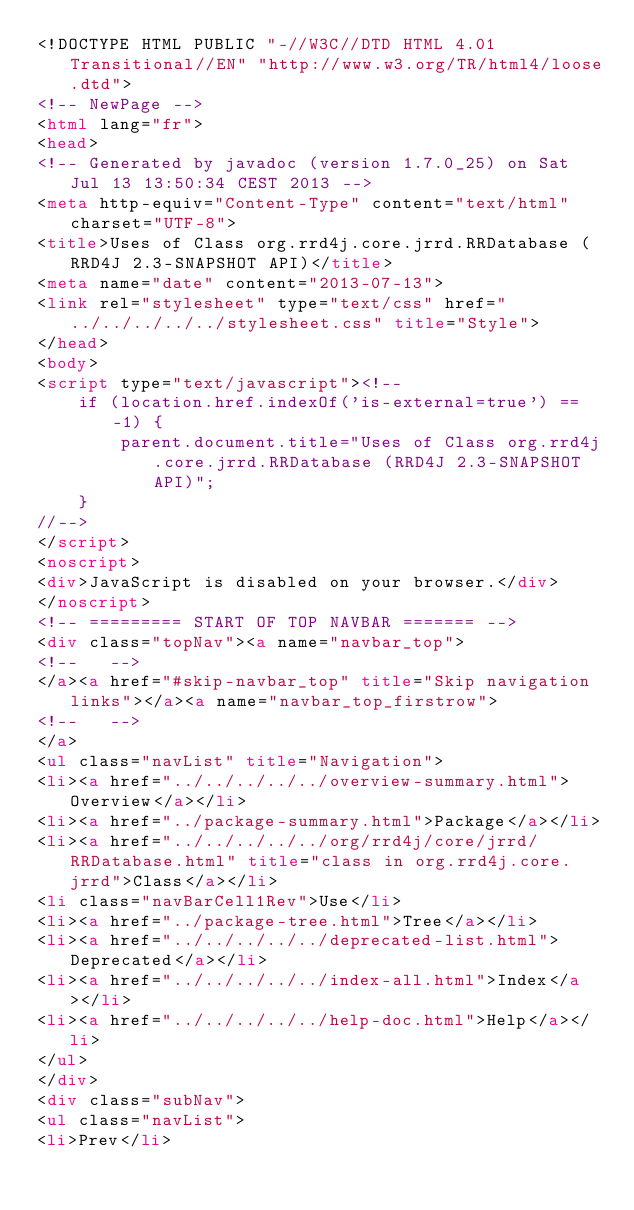<code> <loc_0><loc_0><loc_500><loc_500><_HTML_><!DOCTYPE HTML PUBLIC "-//W3C//DTD HTML 4.01 Transitional//EN" "http://www.w3.org/TR/html4/loose.dtd">
<!-- NewPage -->
<html lang="fr">
<head>
<!-- Generated by javadoc (version 1.7.0_25) on Sat Jul 13 13:50:34 CEST 2013 -->
<meta http-equiv="Content-Type" content="text/html" charset="UTF-8">
<title>Uses of Class org.rrd4j.core.jrrd.RRDatabase (RRD4J 2.3-SNAPSHOT API)</title>
<meta name="date" content="2013-07-13">
<link rel="stylesheet" type="text/css" href="../../../../../stylesheet.css" title="Style">
</head>
<body>
<script type="text/javascript"><!--
    if (location.href.indexOf('is-external=true') == -1) {
        parent.document.title="Uses of Class org.rrd4j.core.jrrd.RRDatabase (RRD4J 2.3-SNAPSHOT API)";
    }
//-->
</script>
<noscript>
<div>JavaScript is disabled on your browser.</div>
</noscript>
<!-- ========= START OF TOP NAVBAR ======= -->
<div class="topNav"><a name="navbar_top">
<!--   -->
</a><a href="#skip-navbar_top" title="Skip navigation links"></a><a name="navbar_top_firstrow">
<!--   -->
</a>
<ul class="navList" title="Navigation">
<li><a href="../../../../../overview-summary.html">Overview</a></li>
<li><a href="../package-summary.html">Package</a></li>
<li><a href="../../../../../org/rrd4j/core/jrrd/RRDatabase.html" title="class in org.rrd4j.core.jrrd">Class</a></li>
<li class="navBarCell1Rev">Use</li>
<li><a href="../package-tree.html">Tree</a></li>
<li><a href="../../../../../deprecated-list.html">Deprecated</a></li>
<li><a href="../../../../../index-all.html">Index</a></li>
<li><a href="../../../../../help-doc.html">Help</a></li>
</ul>
</div>
<div class="subNav">
<ul class="navList">
<li>Prev</li></code> 